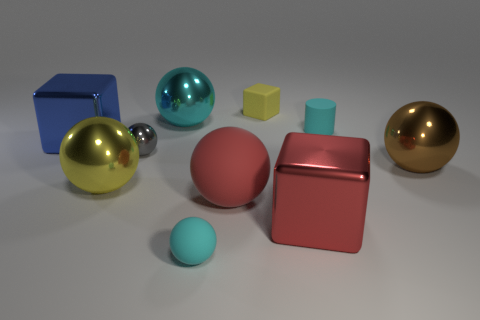Is the number of brown things that are behind the gray object greater than the number of cubes?
Make the answer very short. No. Does the matte cube have the same color as the metal ball that is to the right of the cyan metal sphere?
Offer a terse response. No. Are there an equal number of cyan things to the right of the red metal object and big red balls left of the large brown sphere?
Your answer should be very brief. Yes. There is a yellow object that is to the left of the small cyan ball; what material is it?
Your answer should be very brief. Metal. How many objects are either large cubes to the left of the rubber cube or small blocks?
Ensure brevity in your answer.  2. What number of other objects are there of the same shape as the yellow metallic thing?
Provide a succinct answer. 5. There is a yellow object to the right of the large cyan shiny object; is it the same shape as the gray metallic object?
Provide a succinct answer. No. Are there any big cyan objects behind the small yellow matte thing?
Keep it short and to the point. No. What number of small objects are cyan blocks or yellow blocks?
Offer a very short reply. 1. Are the large blue object and the large yellow thing made of the same material?
Make the answer very short. Yes. 